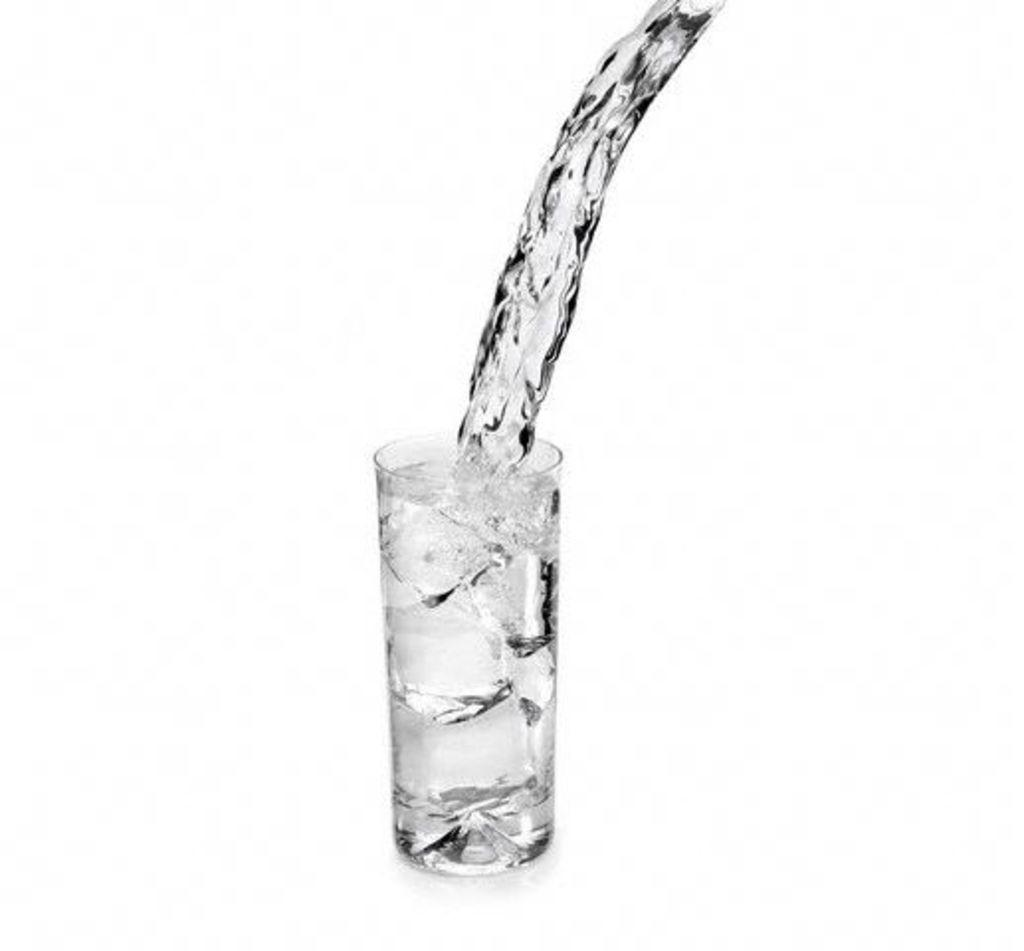What is in the glass that is visible in the image? There is a glass full of water in the image. What type of music can be heard playing in the background of the image? There is no music or background noise mentioned in the image, as it only features a glass full of water. 